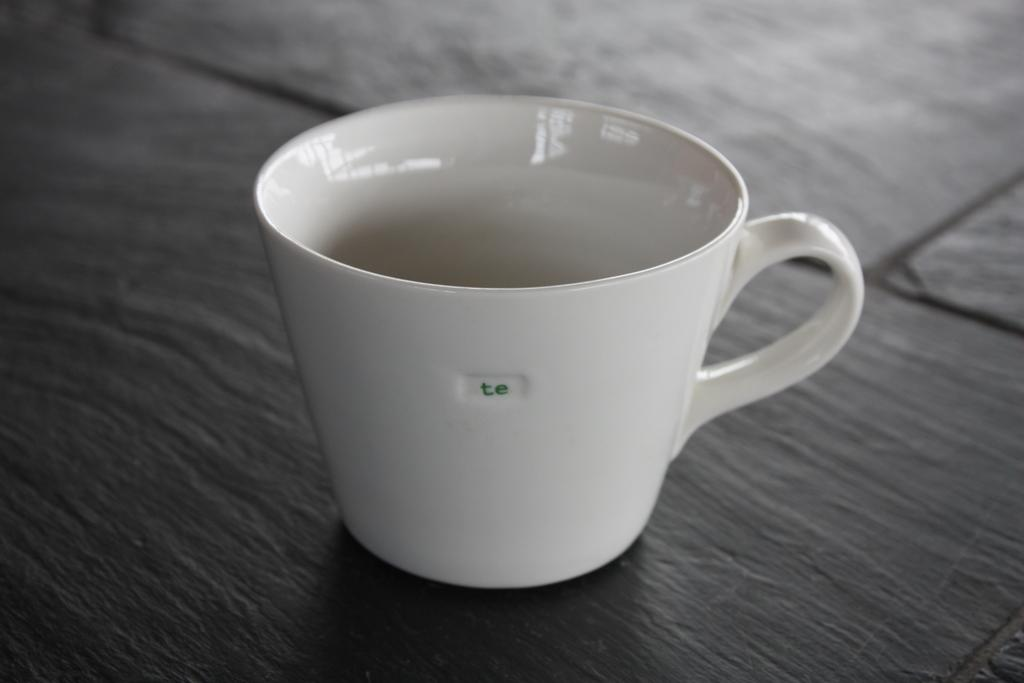<image>
Give a short and clear explanation of the subsequent image. A white coffee cup with nothing in it is decorated with a small green "te" on the side. 